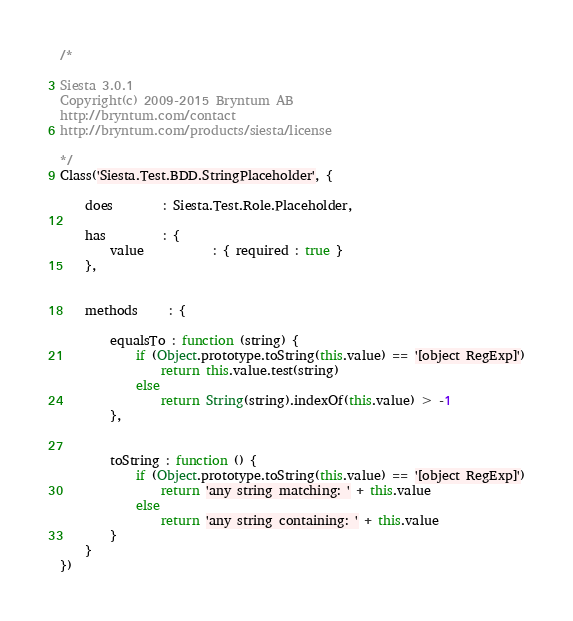Convert code to text. <code><loc_0><loc_0><loc_500><loc_500><_JavaScript_>/*

Siesta 3.0.1
Copyright(c) 2009-2015 Bryntum AB
http://bryntum.com/contact
http://bryntum.com/products/siesta/license

*/
Class('Siesta.Test.BDD.StringPlaceholder', {
    
    does        : Siesta.Test.Role.Placeholder,
    
    has         : {
        value           : { required : true }
    },
    
    
    methods     : {
        
        equalsTo : function (string) {
            if (Object.prototype.toString(this.value) == '[object RegExp]')
                return this.value.test(string)
            else
                return String(string).indexOf(this.value) > -1
        },
        
        
        toString : function () {
            if (Object.prototype.toString(this.value) == '[object RegExp]')
                return 'any string matching: ' + this.value
            else
                return 'any string containing: ' + this.value
        }
    }
})
</code> 